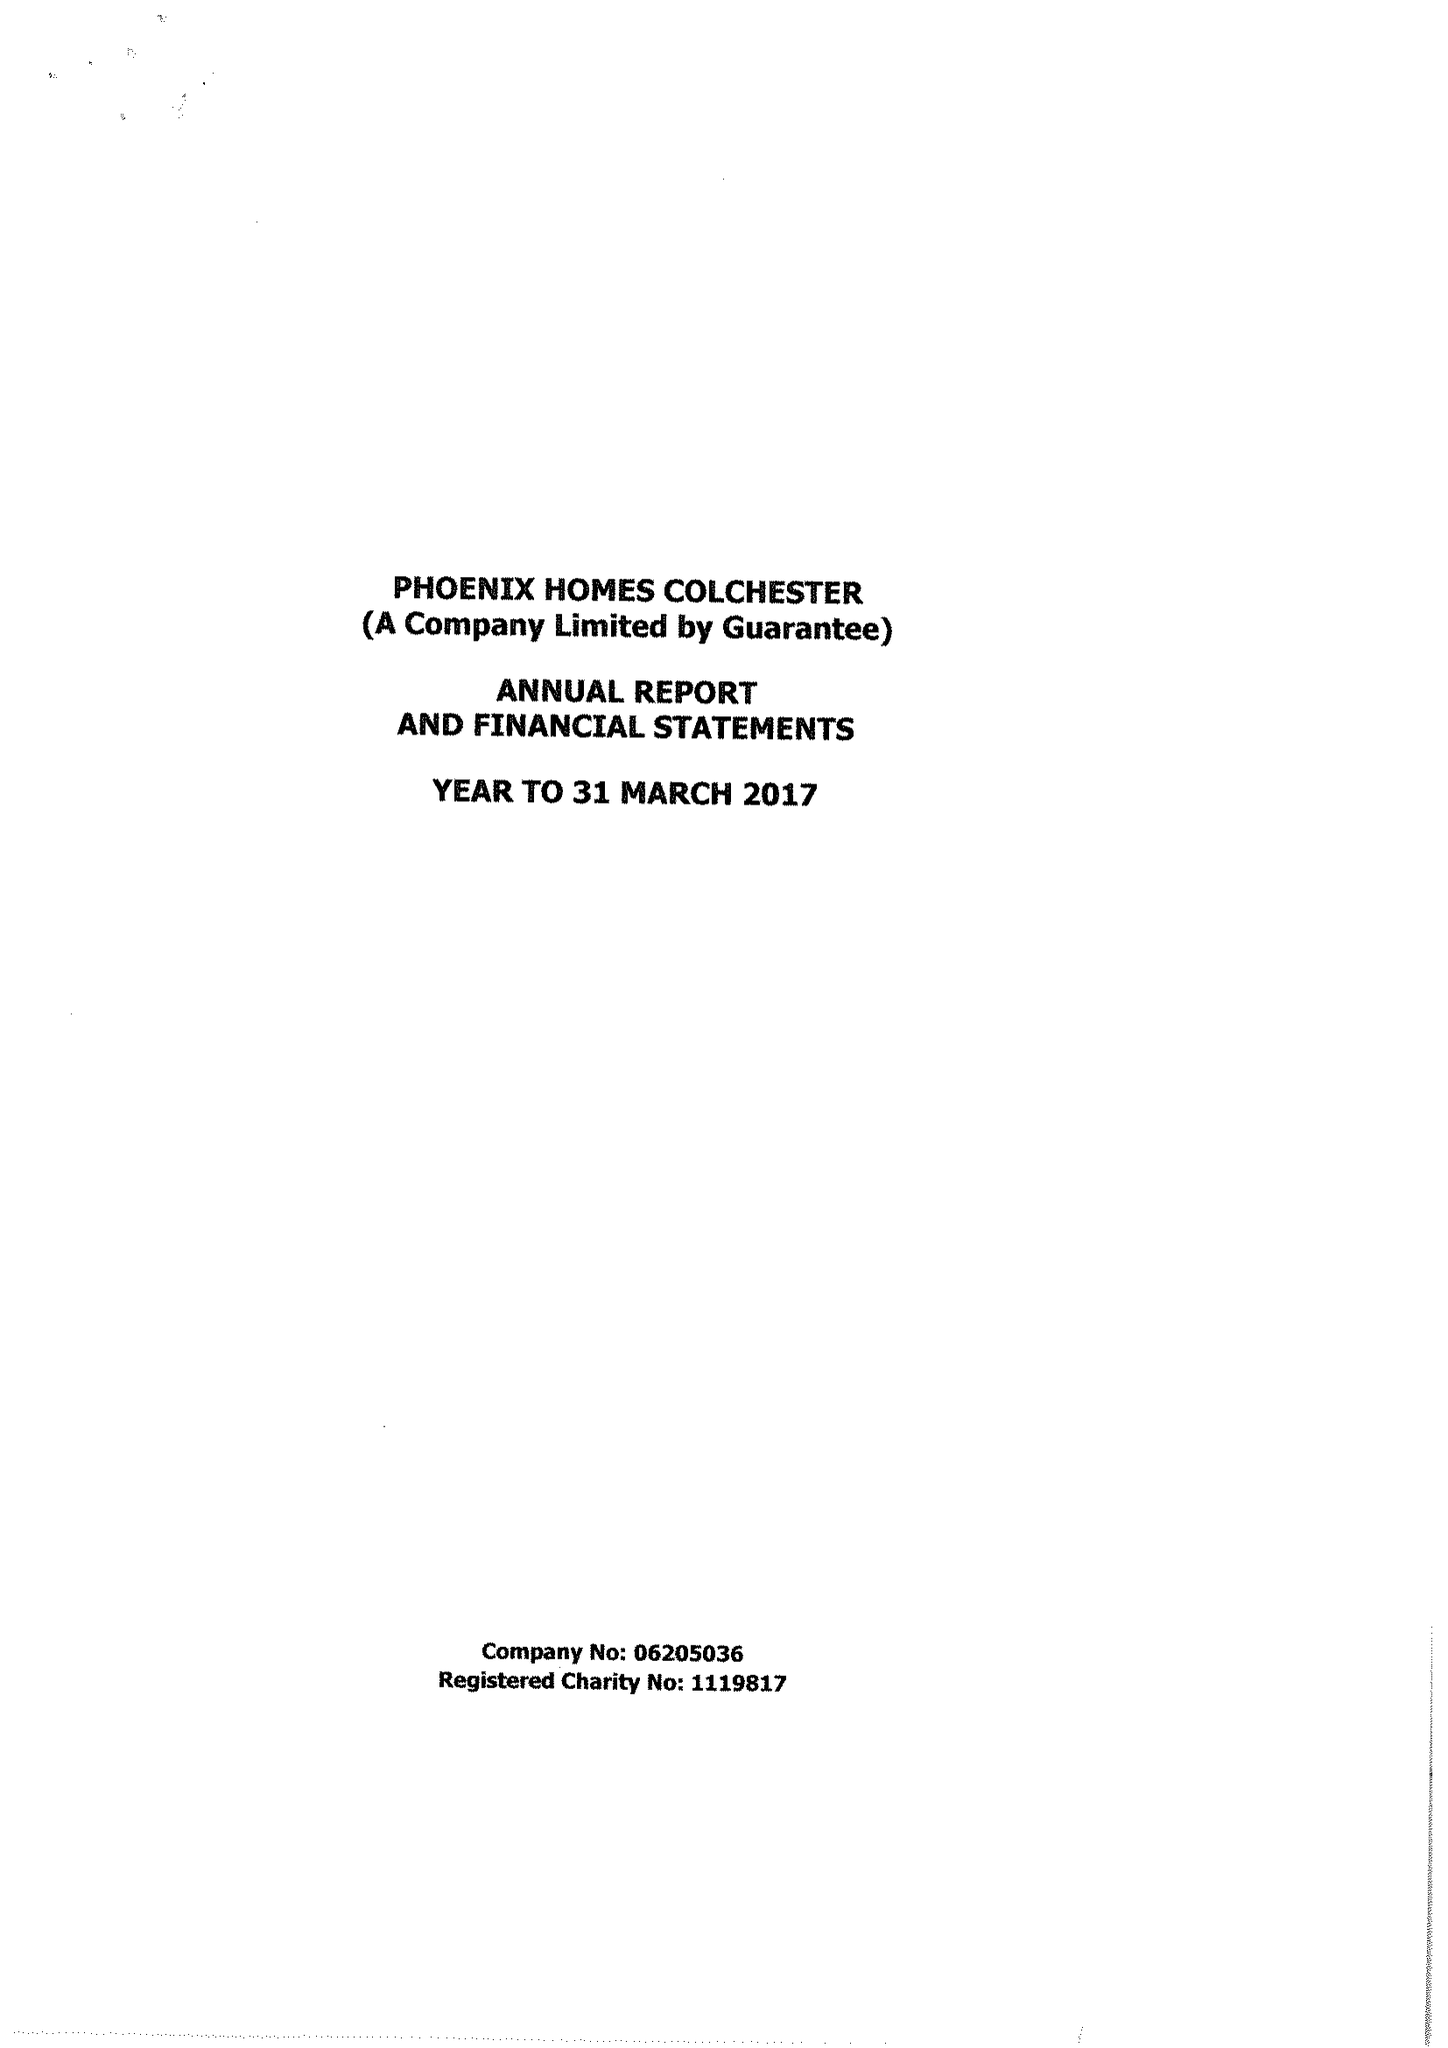What is the value for the spending_annually_in_british_pounds?
Answer the question using a single word or phrase. 421804.00 